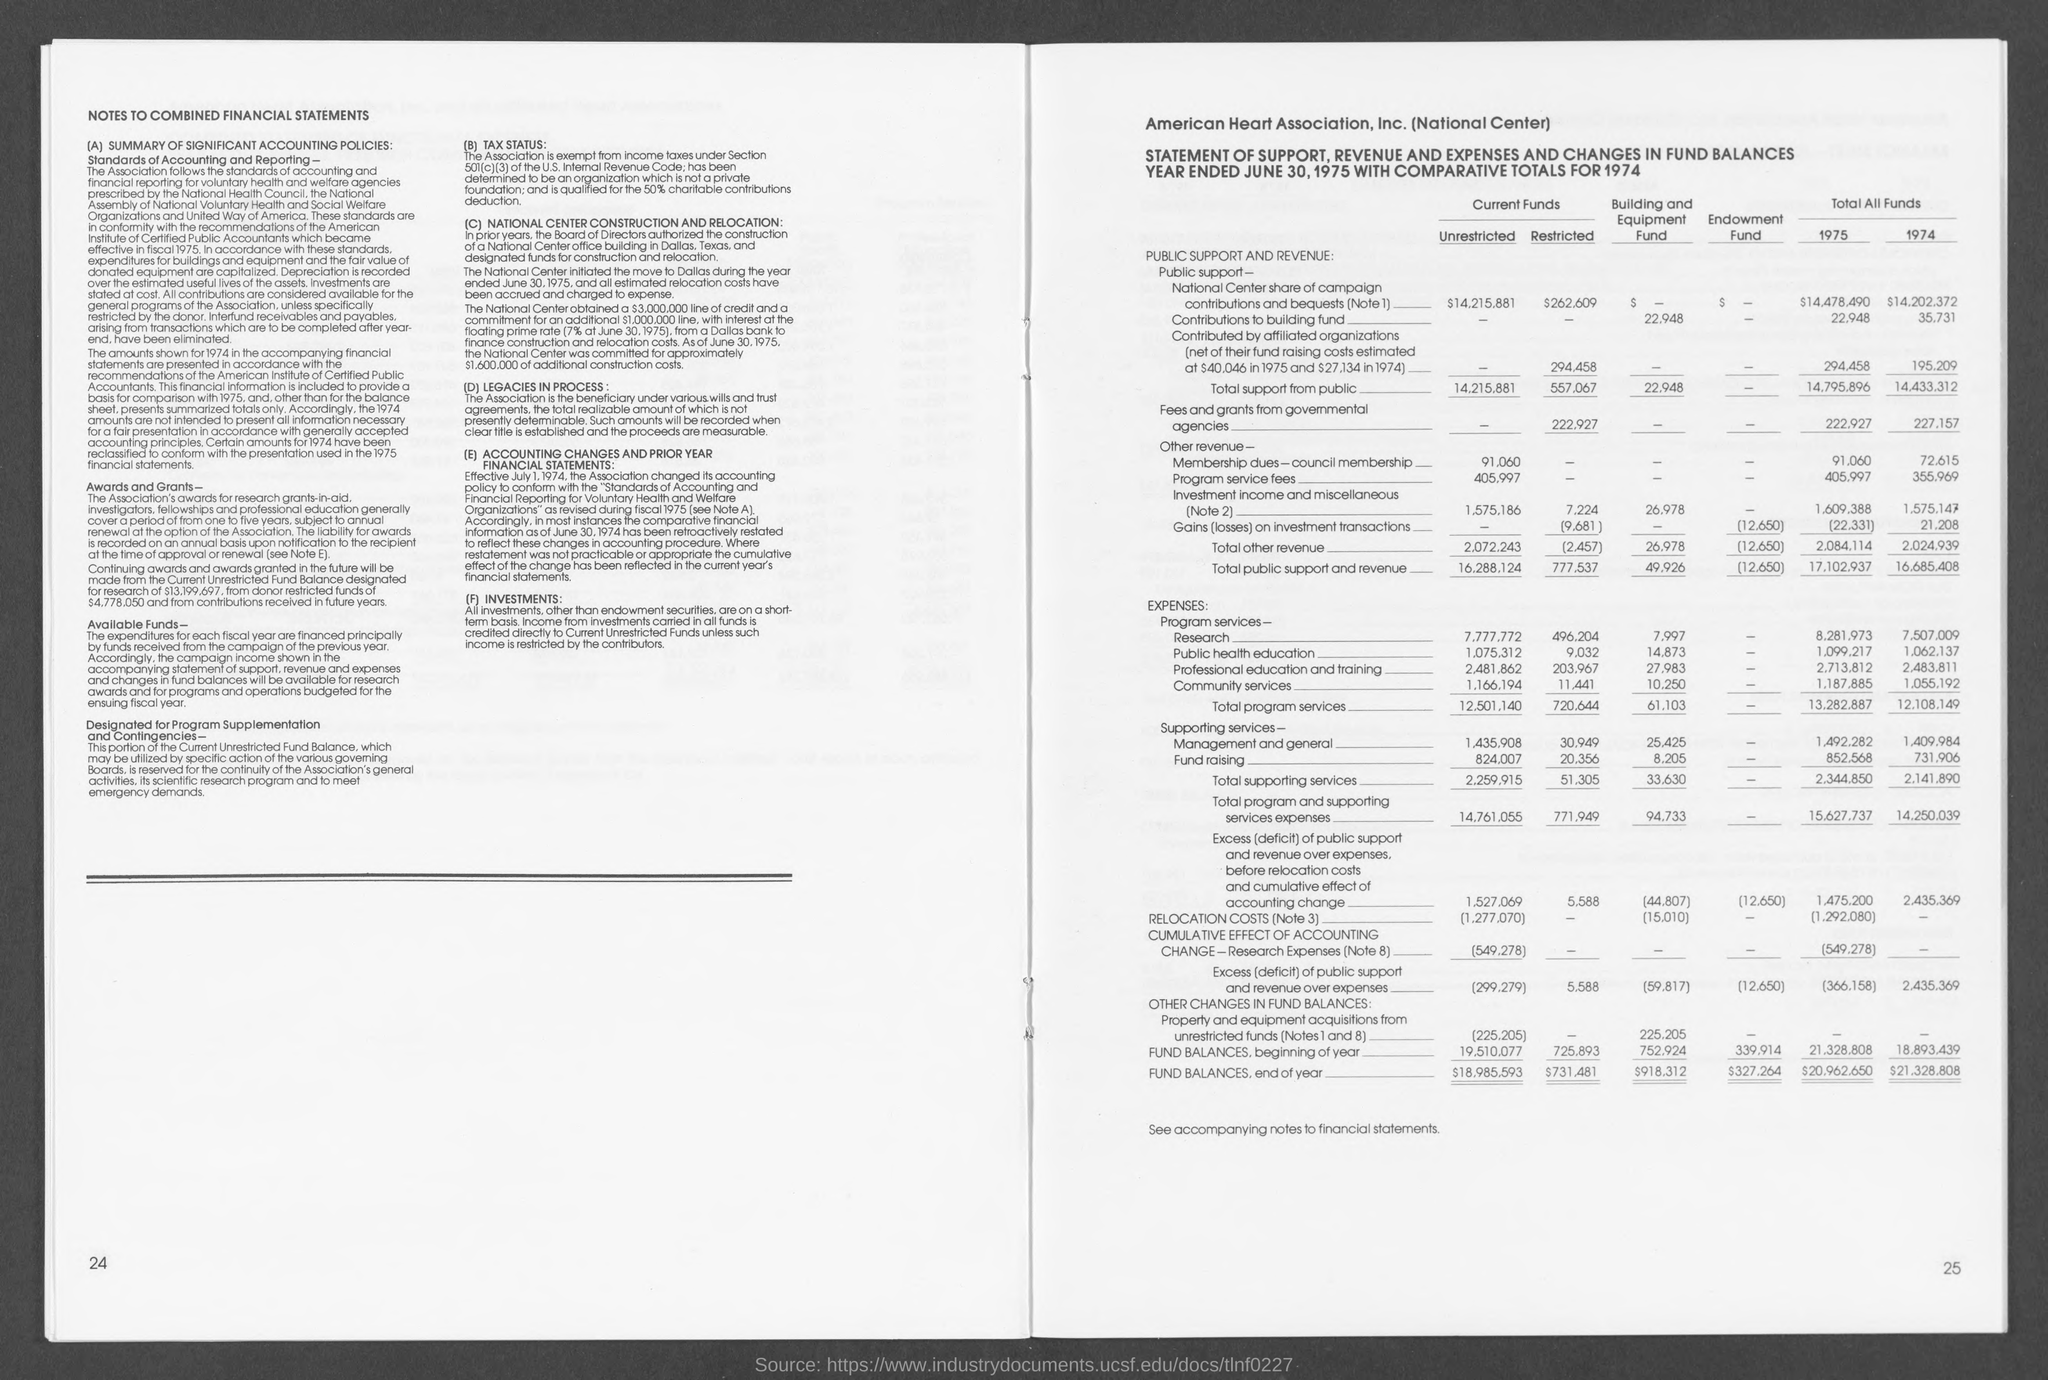Outline some significant characteristics in this image. The association's awards are subject to annual renewal at the option of the association. 